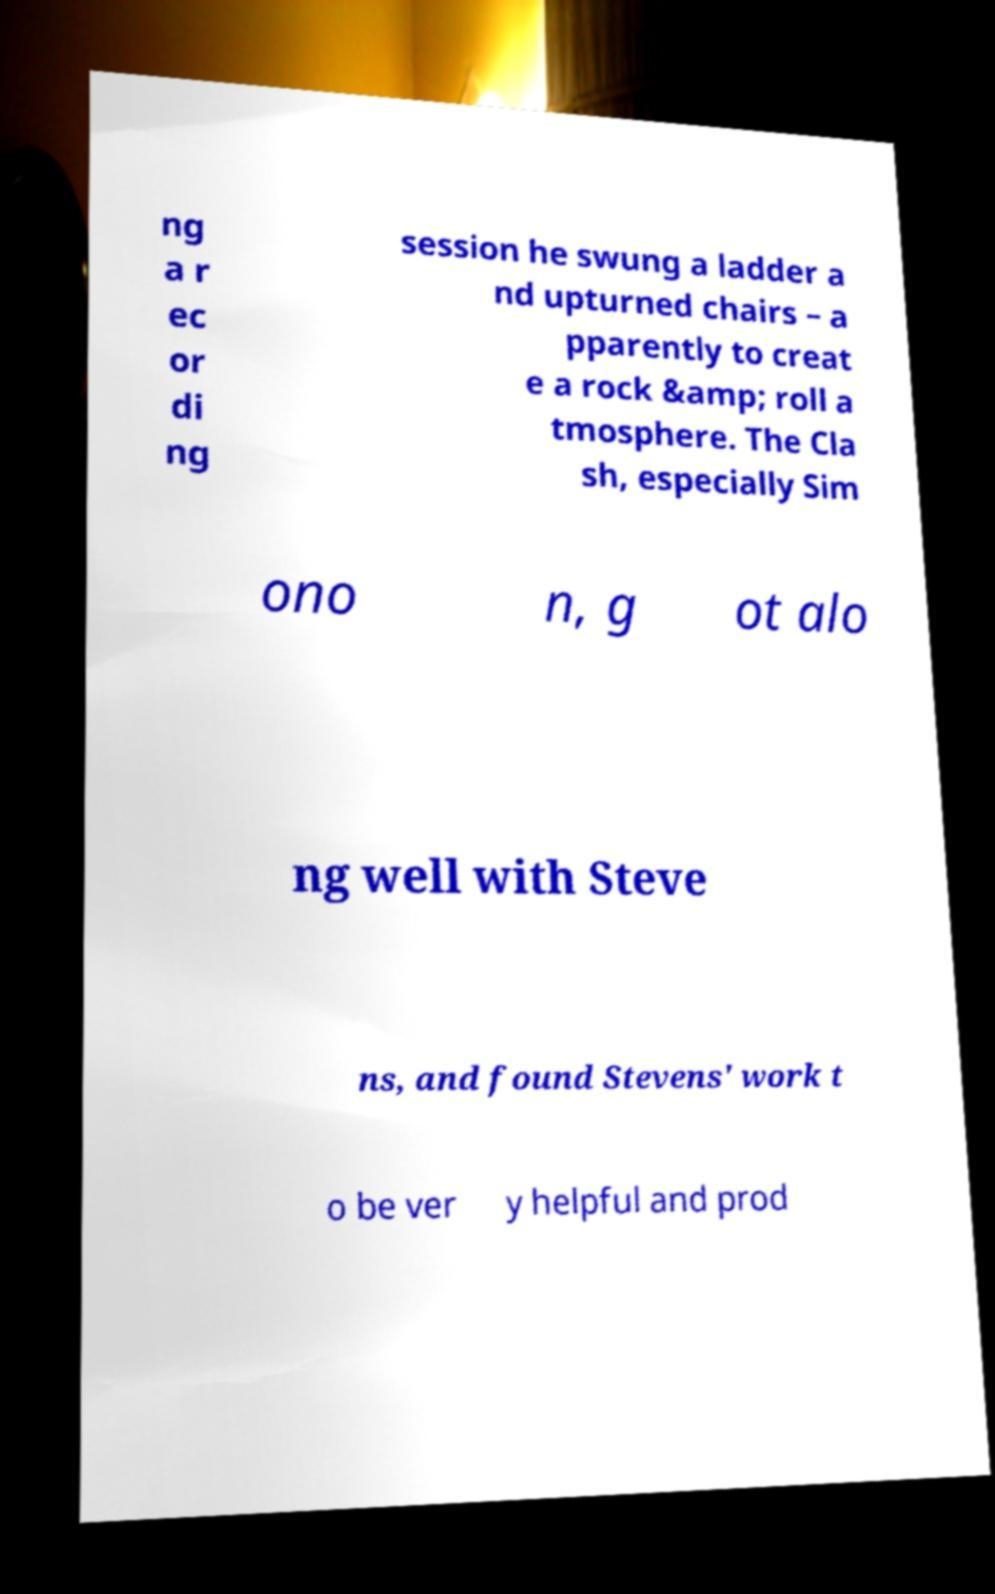I need the written content from this picture converted into text. Can you do that? ng a r ec or di ng session he swung a ladder a nd upturned chairs – a pparently to creat e a rock &amp; roll a tmosphere. The Cla sh, especially Sim ono n, g ot alo ng well with Steve ns, and found Stevens' work t o be ver y helpful and prod 